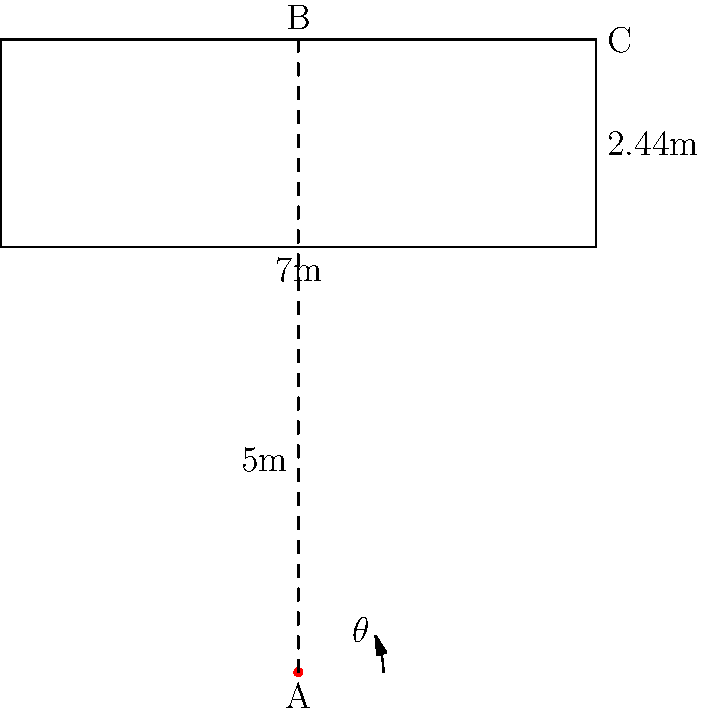During a crucial match at the Olympiastadion, a Hertha BSC rising star takes a shot from 5 meters in front of the goal post's center. If the goal post is 7 meters wide and 2.44 meters high, what is the angle $\theta$ (in degrees) between the ground and the player's shot if they aim for the top right corner of the goal? Let's approach this step-by-step:

1) We can treat this as a right-angled triangle problem. The player's position is point A, the top of the shot's trajectory is point B, and the top right corner of the goal is point C.

2) We know:
   - The distance from the player to the goal line is 5 meters
   - Half the width of the goal is 3.5 meters (7/2)
   - The height of the goal is 2.44 meters

3) We need to find the angle $\theta$ at point A.

4) In the right-angled triangle ABC:
   - The adjacent side (ground to goal) is 5 meters
   - The opposite side is the hypotenuse of another right-angled triangle

5) For the smaller triangle (goal post corner):
   - Base = 3.5 meters
   - Height = 2.44 meters
   - Hypotenuse = $\sqrt{3.5^2 + 2.44^2} = \sqrt{12.25 + 5.9536} = \sqrt{18.2036} \approx 4.2665$ meters

6) Now we have a right-angled triangle where:
   - Adjacent = 5 meters
   - Opposite = 4.2665 meters

7) We can use the arctangent function to find $\theta$:

   $\theta = \arctan(\frac{\text{opposite}}{\text{adjacent}}) = \arctan(\frac{4.2665}{5})$

8) Calculate:
   $\theta = \arctan(0.8533) \approx 40.48°$
Answer: $40.48°$ 